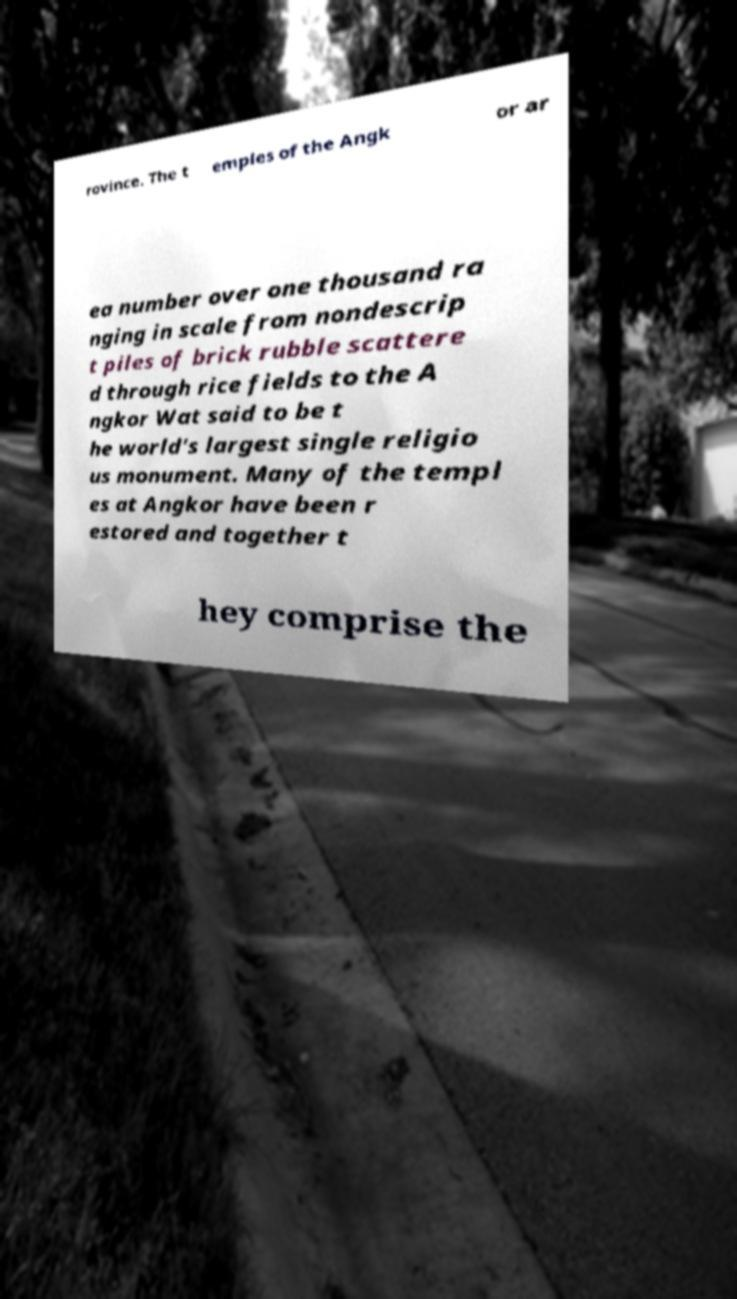Please read and relay the text visible in this image. What does it say? rovince. The t emples of the Angk or ar ea number over one thousand ra nging in scale from nondescrip t piles of brick rubble scattere d through rice fields to the A ngkor Wat said to be t he world's largest single religio us monument. Many of the templ es at Angkor have been r estored and together t hey comprise the 